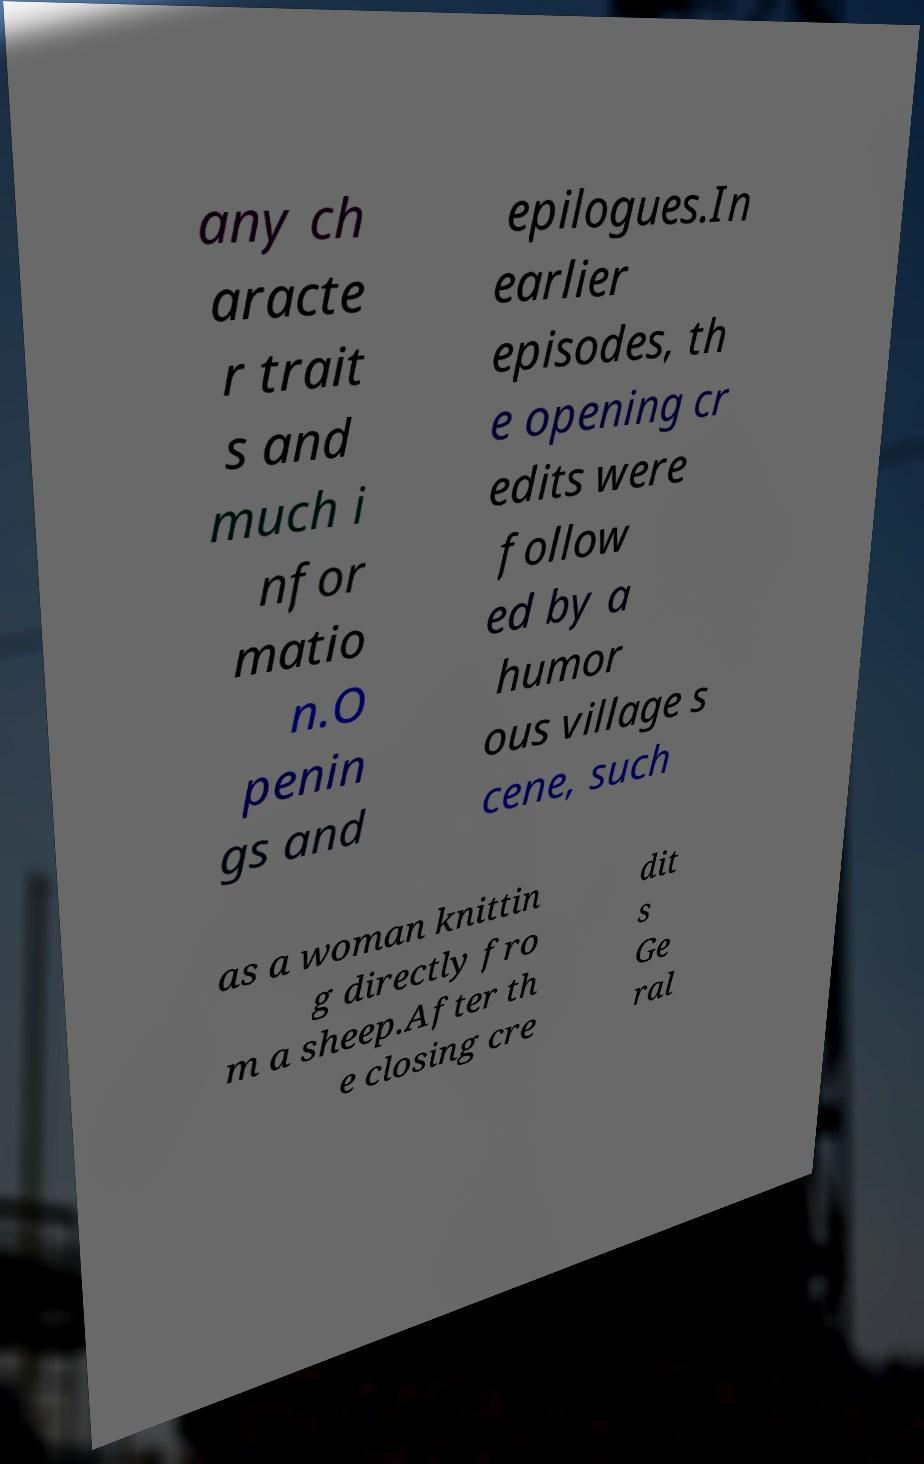Please identify and transcribe the text found in this image. any ch aracte r trait s and much i nfor matio n.O penin gs and epilogues.In earlier episodes, th e opening cr edits were follow ed by a humor ous village s cene, such as a woman knittin g directly fro m a sheep.After th e closing cre dit s Ge ral 